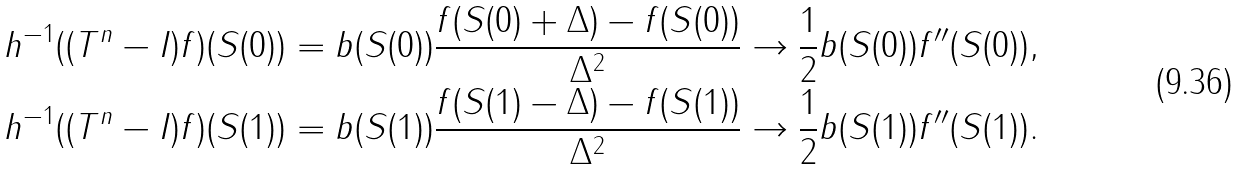Convert formula to latex. <formula><loc_0><loc_0><loc_500><loc_500>h ^ { - 1 } ( ( T ^ { n } - I ) f ) ( S ( 0 ) ) & = b ( S ( 0 ) ) \frac { f ( S ( 0 ) + \Delta ) - f ( S ( 0 ) ) } { \Delta ^ { 2 } } \to \frac { 1 } { 2 } b ( S ( 0 ) ) f ^ { \prime \prime } ( S ( 0 ) ) , \\ h ^ { - 1 } ( ( T ^ { n } - I ) f ) ( S ( 1 ) ) & = b ( S ( 1 ) ) \frac { f ( S ( 1 ) - \Delta ) - f ( S ( 1 ) ) } { \Delta ^ { 2 } } \to \frac { 1 } { 2 } b ( S ( 1 ) ) f ^ { \prime \prime } ( S ( 1 ) ) .</formula> 